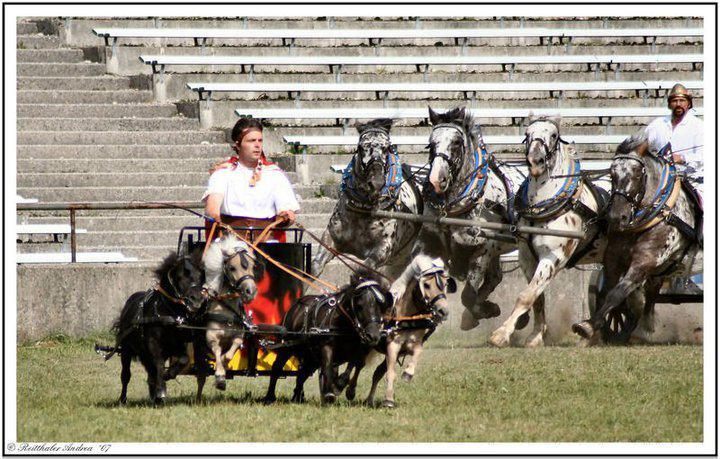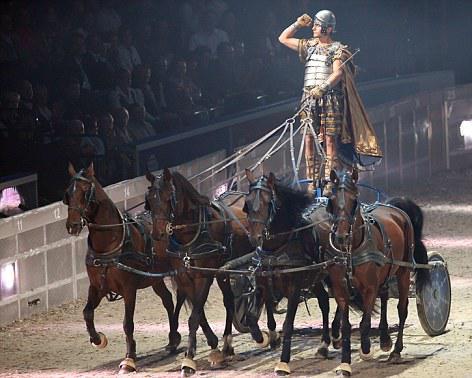The first image is the image on the left, the second image is the image on the right. Evaluate the accuracy of this statement regarding the images: "There are brown horses shown in at least one of the images.". Is it true? Answer yes or no. Yes. The first image is the image on the left, the second image is the image on the right. Examine the images to the left and right. Is the description "At least one image shows a cart pulled by four horses." accurate? Answer yes or no. Yes. 